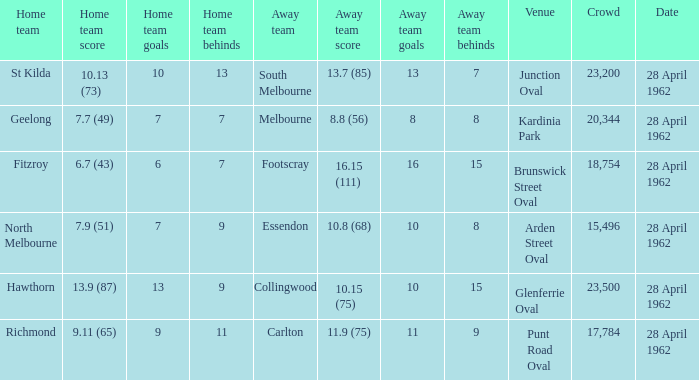At what venue did an away team score 10.15 (75)? Glenferrie Oval. 